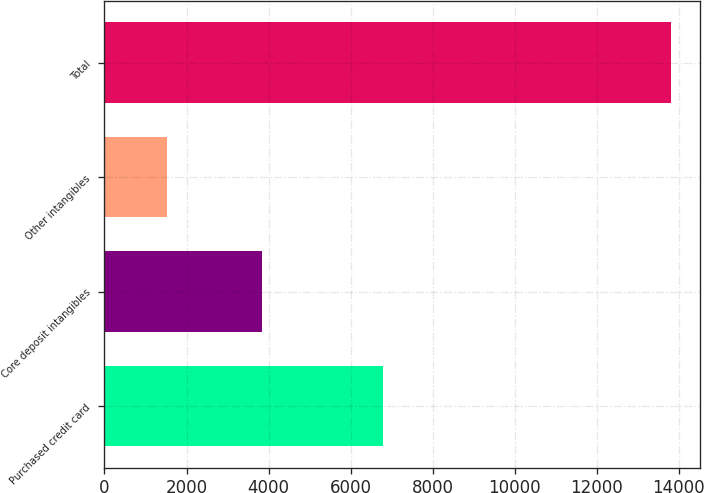Convert chart to OTSL. <chart><loc_0><loc_0><loc_500><loc_500><bar_chart><fcel>Purchased credit card<fcel>Core deposit intangibles<fcel>Other intangibles<fcel>Total<nl><fcel>6790<fcel>3850<fcel>1525<fcel>13815<nl></chart> 